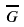<formula> <loc_0><loc_0><loc_500><loc_500>\overline { G }</formula> 